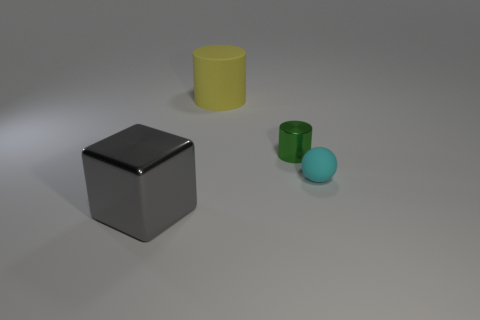Is there a cyan thing that has the same size as the matte cylinder?
Keep it short and to the point. No. What is the shape of the tiny matte object?
Give a very brief answer. Sphere. What number of cylinders are either tiny red metallic objects or large metal objects?
Offer a terse response. 0. Are there the same number of big yellow matte things behind the shiny cube and big gray metallic blocks behind the small green shiny thing?
Your answer should be compact. No. There is a object that is left of the rubber thing that is left of the tiny matte object; what number of small spheres are behind it?
Offer a terse response. 1. There is a matte cylinder; is it the same color as the small shiny cylinder that is behind the tiny cyan rubber ball?
Offer a very short reply. No. Is the number of gray objects to the right of the small cyan rubber object greater than the number of green metal blocks?
Provide a short and direct response. No. What number of things are either objects in front of the tiny metal thing or objects right of the metallic block?
Keep it short and to the point. 4. The green cylinder that is made of the same material as the cube is what size?
Provide a short and direct response. Small. Is the shape of the thing that is in front of the cyan rubber sphere the same as  the cyan matte thing?
Offer a terse response. No. 